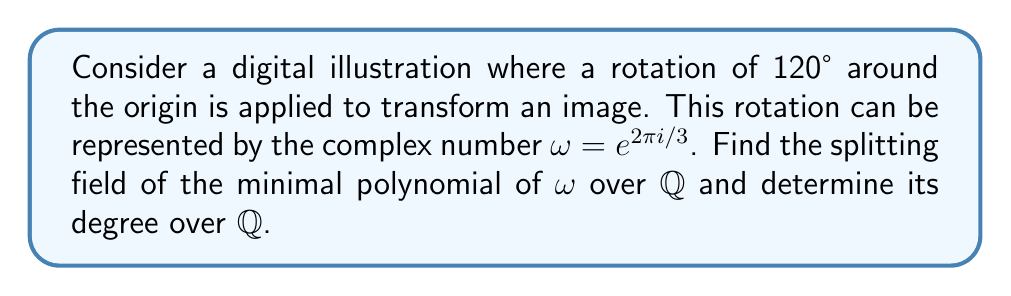Provide a solution to this math problem. 1) First, we need to find the minimal polynomial of $\omega$ over $\mathbb{Q}$:
   $\omega = e^{2\pi i/3}$ is a primitive 3rd root of unity.
   The minimal polynomial for a primitive 3rd root of unity is $x^2 + x + 1$.

2) To find the splitting field, we need to adjoin $\omega$ to $\mathbb{Q}$:
   $K = \mathbb{Q}(\omega)$

3) The roots of $x^2 + x + 1$ are $\omega$ and $\omega^2$:
   $\omega = e^{2\pi i/3}$ and $\omega^2 = e^{4\pi i/3}$

4) Both roots are in $K = \mathbb{Q}(\omega)$, so this is the splitting field.

5) To find the degree of the extension:
   $[\mathbb{Q}(\omega):\mathbb{Q}] = \text{deg}(x^2 + x + 1) = 2$

6) Geometrically, this means the rotation can be achieved using a 2-dimensional vector space over $\mathbb{Q}$, which aligns with the 2D nature of the illustration.
Answer: $\mathbb{Q}(\omega)$, degree 2 